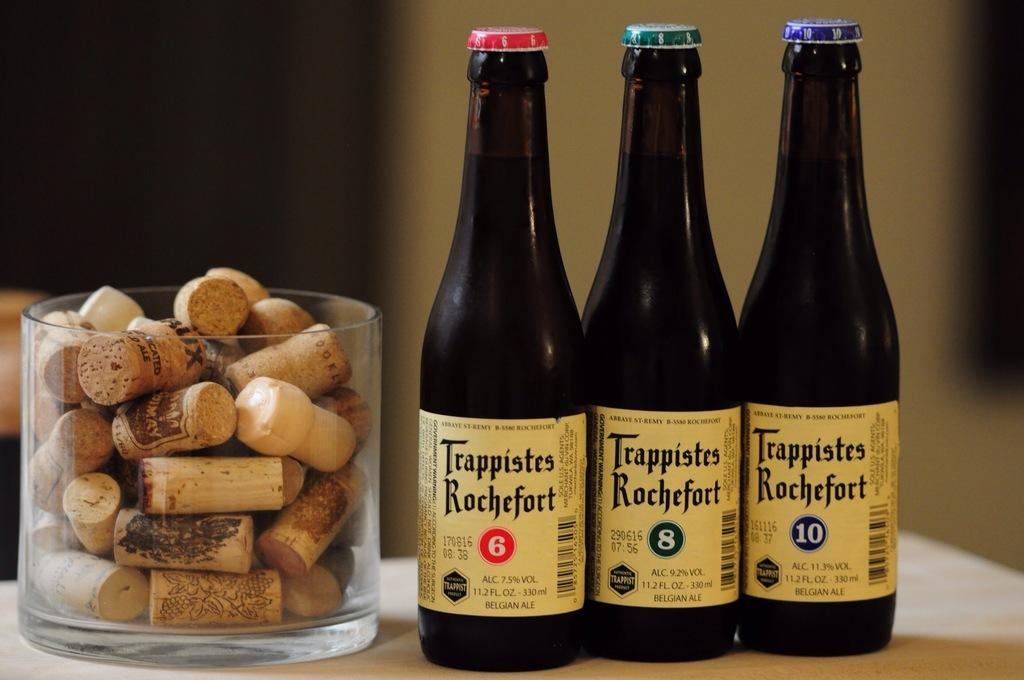<image>
Create a compact narrative representing the image presented. Three different bottle of Trappistes Rochefort sit next to a bowl of corks. 